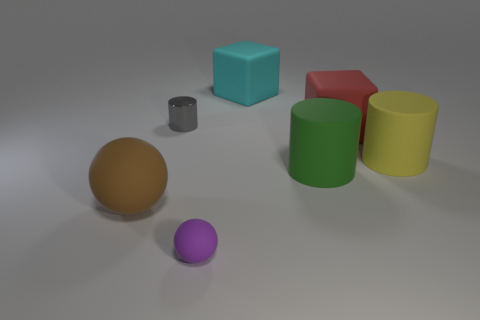Subtract all matte cylinders. How many cylinders are left? 1 Subtract all gray cylinders. How many cylinders are left? 2 Subtract all blocks. How many objects are left? 5 Add 4 cyan matte objects. How many cyan matte objects are left? 5 Add 1 large blocks. How many large blocks exist? 3 Add 1 yellow objects. How many objects exist? 8 Subtract 0 brown blocks. How many objects are left? 7 Subtract 2 cylinders. How many cylinders are left? 1 Subtract all yellow balls. Subtract all gray blocks. How many balls are left? 2 Subtract all purple blocks. How many gray cylinders are left? 1 